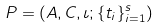<formula> <loc_0><loc_0><loc_500><loc_500>P = ( A , C , \iota ; \{ t _ { i } \} _ { i = 1 } ^ { s } )</formula> 